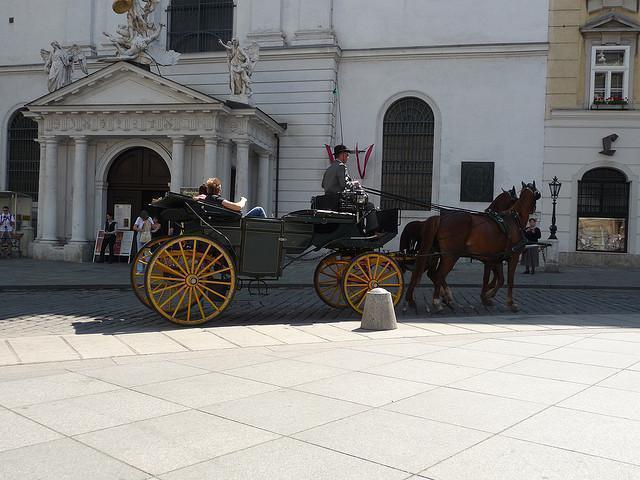What is being held by the person sitting highest?
From the following four choices, select the correct answer to address the question.
Options: Wagon wheels, spurs, tickets, reins. Reins. 